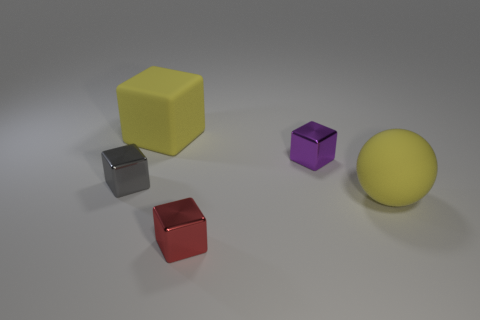Are the yellow thing right of the red cube and the tiny purple cube made of the same material?
Provide a short and direct response. No. Are there fewer shiny things behind the yellow block than brown rubber cubes?
Give a very brief answer. No. What number of metal objects are yellow objects or purple cylinders?
Your answer should be compact. 0. Is the matte ball the same color as the matte cube?
Make the answer very short. Yes. Does the tiny metal object to the left of the large yellow cube have the same shape as the big yellow rubber object behind the gray metallic thing?
Offer a very short reply. Yes. What number of things are big matte things or large yellow things in front of the small purple metal thing?
Your answer should be compact. 2. How many other things are the same size as the yellow matte sphere?
Offer a terse response. 1. Does the tiny block behind the gray object have the same material as the small block that is left of the small red object?
Your response must be concise. Yes. There is a gray cube; how many small gray shiny things are to the right of it?
Offer a very short reply. 0. What number of brown objects are either small metallic cubes or cubes?
Offer a very short reply. 0. 